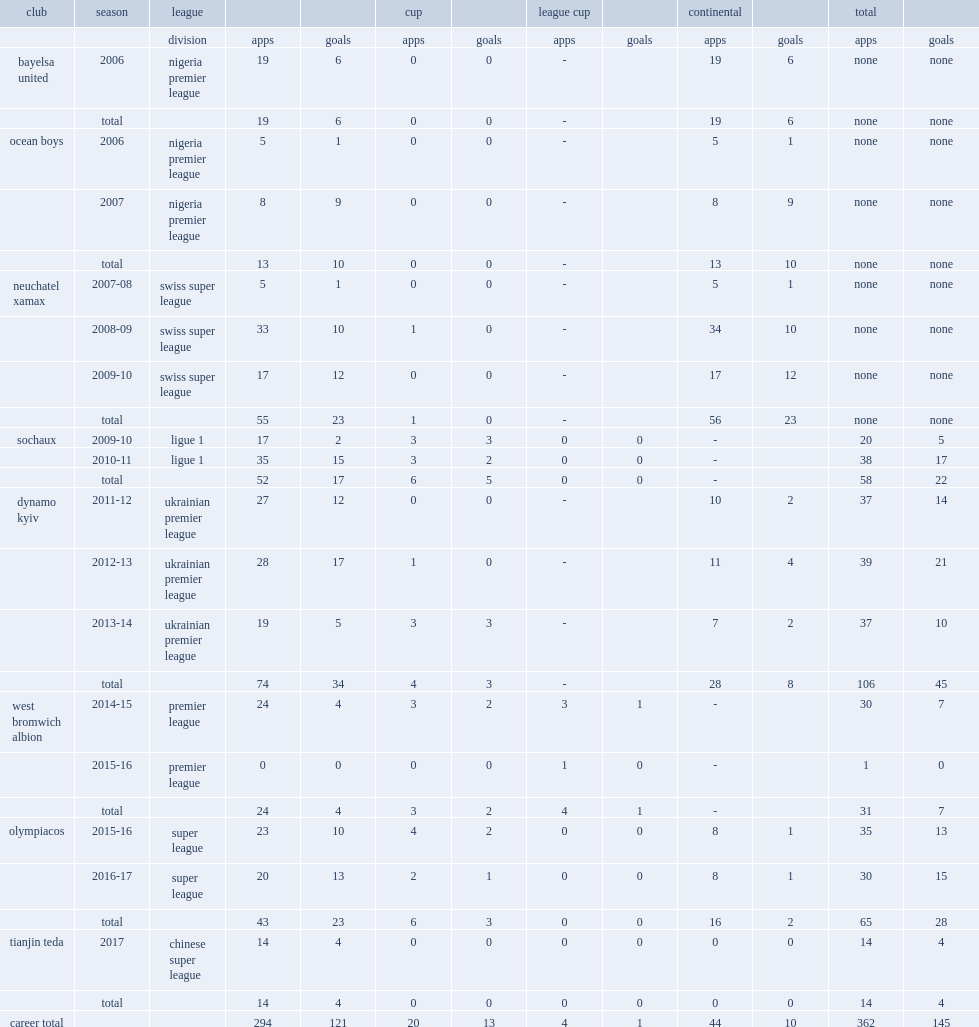Which league did brown ideye leave olympiakos for side tianjin teda in 2017? Chinese super league. 